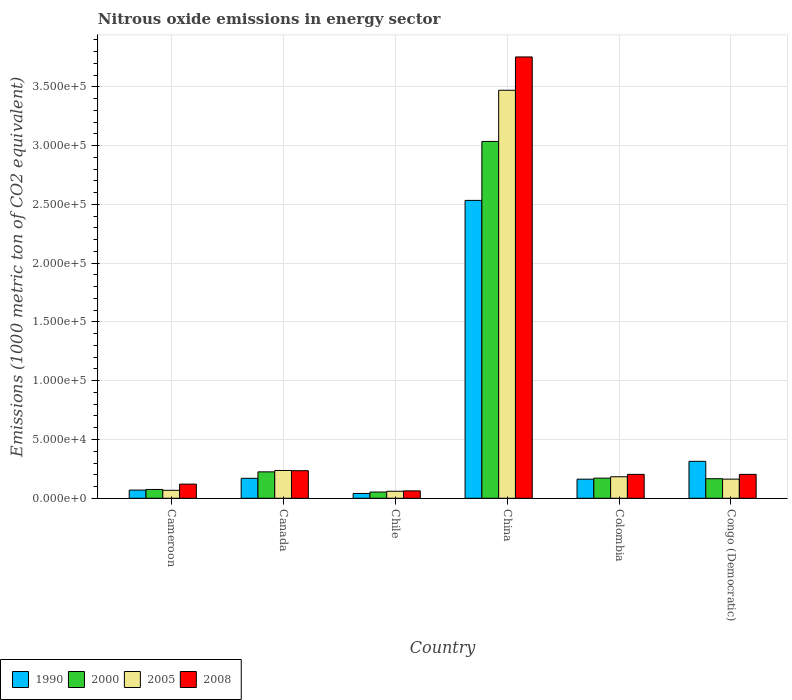How many different coloured bars are there?
Keep it short and to the point. 4. Are the number of bars on each tick of the X-axis equal?
Keep it short and to the point. Yes. What is the label of the 1st group of bars from the left?
Provide a succinct answer. Cameroon. In how many cases, is the number of bars for a given country not equal to the number of legend labels?
Your answer should be compact. 0. What is the amount of nitrous oxide emitted in 2008 in Canada?
Offer a very short reply. 2.34e+04. Across all countries, what is the maximum amount of nitrous oxide emitted in 2005?
Give a very brief answer. 3.47e+05. Across all countries, what is the minimum amount of nitrous oxide emitted in 2000?
Your answer should be very brief. 5305.7. What is the total amount of nitrous oxide emitted in 2008 in the graph?
Give a very brief answer. 4.58e+05. What is the difference between the amount of nitrous oxide emitted in 2005 in Colombia and that in Congo (Democratic)?
Offer a very short reply. 2014.7. What is the difference between the amount of nitrous oxide emitted in 2000 in Cameroon and the amount of nitrous oxide emitted in 1990 in China?
Your answer should be compact. -2.46e+05. What is the average amount of nitrous oxide emitted in 2000 per country?
Offer a very short reply. 6.21e+04. What is the difference between the amount of nitrous oxide emitted of/in 2000 and amount of nitrous oxide emitted of/in 2005 in Cameroon?
Ensure brevity in your answer.  719.7. What is the ratio of the amount of nitrous oxide emitted in 1990 in Chile to that in China?
Provide a short and direct response. 0.02. What is the difference between the highest and the second highest amount of nitrous oxide emitted in 2008?
Your answer should be very brief. 3108.7. What is the difference between the highest and the lowest amount of nitrous oxide emitted in 2000?
Ensure brevity in your answer.  2.98e+05. In how many countries, is the amount of nitrous oxide emitted in 2000 greater than the average amount of nitrous oxide emitted in 2000 taken over all countries?
Offer a very short reply. 1. Is the sum of the amount of nitrous oxide emitted in 2008 in Canada and Chile greater than the maximum amount of nitrous oxide emitted in 1990 across all countries?
Your response must be concise. No. Is it the case that in every country, the sum of the amount of nitrous oxide emitted in 2000 and amount of nitrous oxide emitted in 2005 is greater than the sum of amount of nitrous oxide emitted in 2008 and amount of nitrous oxide emitted in 1990?
Your answer should be compact. No. What does the 4th bar from the left in Colombia represents?
Your answer should be compact. 2008. What does the 4th bar from the right in China represents?
Provide a succinct answer. 1990. Are all the bars in the graph horizontal?
Offer a very short reply. No. How many countries are there in the graph?
Your answer should be compact. 6. Are the values on the major ticks of Y-axis written in scientific E-notation?
Offer a very short reply. Yes. Does the graph contain any zero values?
Make the answer very short. No. Does the graph contain grids?
Provide a succinct answer. Yes. How are the legend labels stacked?
Your answer should be compact. Horizontal. What is the title of the graph?
Your answer should be compact. Nitrous oxide emissions in energy sector. What is the label or title of the X-axis?
Make the answer very short. Country. What is the label or title of the Y-axis?
Provide a short and direct response. Emissions (1000 metric ton of CO2 equivalent). What is the Emissions (1000 metric ton of CO2 equivalent) in 1990 in Cameroon?
Ensure brevity in your answer.  6970.1. What is the Emissions (1000 metric ton of CO2 equivalent) in 2000 in Cameroon?
Offer a very short reply. 7501.6. What is the Emissions (1000 metric ton of CO2 equivalent) in 2005 in Cameroon?
Offer a very short reply. 6781.9. What is the Emissions (1000 metric ton of CO2 equivalent) of 2008 in Cameroon?
Keep it short and to the point. 1.21e+04. What is the Emissions (1000 metric ton of CO2 equivalent) of 1990 in Canada?
Provide a succinct answer. 1.70e+04. What is the Emissions (1000 metric ton of CO2 equivalent) of 2000 in Canada?
Give a very brief answer. 2.25e+04. What is the Emissions (1000 metric ton of CO2 equivalent) in 2005 in Canada?
Provide a succinct answer. 2.36e+04. What is the Emissions (1000 metric ton of CO2 equivalent) in 2008 in Canada?
Provide a succinct answer. 2.34e+04. What is the Emissions (1000 metric ton of CO2 equivalent) in 1990 in Chile?
Your response must be concise. 4097. What is the Emissions (1000 metric ton of CO2 equivalent) of 2000 in Chile?
Offer a very short reply. 5305.7. What is the Emissions (1000 metric ton of CO2 equivalent) in 2005 in Chile?
Ensure brevity in your answer.  5967.8. What is the Emissions (1000 metric ton of CO2 equivalent) in 2008 in Chile?
Your response must be concise. 6312. What is the Emissions (1000 metric ton of CO2 equivalent) in 1990 in China?
Your answer should be compact. 2.53e+05. What is the Emissions (1000 metric ton of CO2 equivalent) in 2000 in China?
Make the answer very short. 3.04e+05. What is the Emissions (1000 metric ton of CO2 equivalent) of 2005 in China?
Give a very brief answer. 3.47e+05. What is the Emissions (1000 metric ton of CO2 equivalent) in 2008 in China?
Your answer should be compact. 3.75e+05. What is the Emissions (1000 metric ton of CO2 equivalent) in 1990 in Colombia?
Provide a short and direct response. 1.63e+04. What is the Emissions (1000 metric ton of CO2 equivalent) of 2000 in Colombia?
Offer a very short reply. 1.71e+04. What is the Emissions (1000 metric ton of CO2 equivalent) of 2005 in Colombia?
Offer a very short reply. 1.83e+04. What is the Emissions (1000 metric ton of CO2 equivalent) of 2008 in Colombia?
Provide a succinct answer. 2.03e+04. What is the Emissions (1000 metric ton of CO2 equivalent) in 1990 in Congo (Democratic)?
Give a very brief answer. 3.14e+04. What is the Emissions (1000 metric ton of CO2 equivalent) of 2000 in Congo (Democratic)?
Keep it short and to the point. 1.66e+04. What is the Emissions (1000 metric ton of CO2 equivalent) in 2005 in Congo (Democratic)?
Keep it short and to the point. 1.63e+04. What is the Emissions (1000 metric ton of CO2 equivalent) of 2008 in Congo (Democratic)?
Your answer should be very brief. 2.03e+04. Across all countries, what is the maximum Emissions (1000 metric ton of CO2 equivalent) in 1990?
Provide a short and direct response. 2.53e+05. Across all countries, what is the maximum Emissions (1000 metric ton of CO2 equivalent) of 2000?
Offer a terse response. 3.04e+05. Across all countries, what is the maximum Emissions (1000 metric ton of CO2 equivalent) of 2005?
Make the answer very short. 3.47e+05. Across all countries, what is the maximum Emissions (1000 metric ton of CO2 equivalent) of 2008?
Your response must be concise. 3.75e+05. Across all countries, what is the minimum Emissions (1000 metric ton of CO2 equivalent) in 1990?
Give a very brief answer. 4097. Across all countries, what is the minimum Emissions (1000 metric ton of CO2 equivalent) in 2000?
Offer a terse response. 5305.7. Across all countries, what is the minimum Emissions (1000 metric ton of CO2 equivalent) of 2005?
Ensure brevity in your answer.  5967.8. Across all countries, what is the minimum Emissions (1000 metric ton of CO2 equivalent) in 2008?
Ensure brevity in your answer.  6312. What is the total Emissions (1000 metric ton of CO2 equivalent) in 1990 in the graph?
Give a very brief answer. 3.29e+05. What is the total Emissions (1000 metric ton of CO2 equivalent) of 2000 in the graph?
Ensure brevity in your answer.  3.73e+05. What is the total Emissions (1000 metric ton of CO2 equivalent) in 2005 in the graph?
Your answer should be compact. 4.18e+05. What is the total Emissions (1000 metric ton of CO2 equivalent) in 2008 in the graph?
Keep it short and to the point. 4.58e+05. What is the difference between the Emissions (1000 metric ton of CO2 equivalent) in 1990 in Cameroon and that in Canada?
Ensure brevity in your answer.  -1.00e+04. What is the difference between the Emissions (1000 metric ton of CO2 equivalent) in 2000 in Cameroon and that in Canada?
Your response must be concise. -1.50e+04. What is the difference between the Emissions (1000 metric ton of CO2 equivalent) of 2005 in Cameroon and that in Canada?
Give a very brief answer. -1.69e+04. What is the difference between the Emissions (1000 metric ton of CO2 equivalent) of 2008 in Cameroon and that in Canada?
Your answer should be very brief. -1.14e+04. What is the difference between the Emissions (1000 metric ton of CO2 equivalent) in 1990 in Cameroon and that in Chile?
Give a very brief answer. 2873.1. What is the difference between the Emissions (1000 metric ton of CO2 equivalent) of 2000 in Cameroon and that in Chile?
Provide a short and direct response. 2195.9. What is the difference between the Emissions (1000 metric ton of CO2 equivalent) of 2005 in Cameroon and that in Chile?
Provide a short and direct response. 814.1. What is the difference between the Emissions (1000 metric ton of CO2 equivalent) in 2008 in Cameroon and that in Chile?
Offer a terse response. 5740.9. What is the difference between the Emissions (1000 metric ton of CO2 equivalent) of 1990 in Cameroon and that in China?
Your answer should be compact. -2.46e+05. What is the difference between the Emissions (1000 metric ton of CO2 equivalent) of 2000 in Cameroon and that in China?
Your answer should be compact. -2.96e+05. What is the difference between the Emissions (1000 metric ton of CO2 equivalent) in 2005 in Cameroon and that in China?
Your answer should be compact. -3.40e+05. What is the difference between the Emissions (1000 metric ton of CO2 equivalent) in 2008 in Cameroon and that in China?
Provide a succinct answer. -3.63e+05. What is the difference between the Emissions (1000 metric ton of CO2 equivalent) in 1990 in Cameroon and that in Colombia?
Offer a very short reply. -9292. What is the difference between the Emissions (1000 metric ton of CO2 equivalent) in 2000 in Cameroon and that in Colombia?
Keep it short and to the point. -9624.9. What is the difference between the Emissions (1000 metric ton of CO2 equivalent) of 2005 in Cameroon and that in Colombia?
Provide a short and direct response. -1.15e+04. What is the difference between the Emissions (1000 metric ton of CO2 equivalent) of 2008 in Cameroon and that in Colombia?
Make the answer very short. -8286.7. What is the difference between the Emissions (1000 metric ton of CO2 equivalent) of 1990 in Cameroon and that in Congo (Democratic)?
Make the answer very short. -2.45e+04. What is the difference between the Emissions (1000 metric ton of CO2 equivalent) of 2000 in Cameroon and that in Congo (Democratic)?
Keep it short and to the point. -9135.6. What is the difference between the Emissions (1000 metric ton of CO2 equivalent) of 2005 in Cameroon and that in Congo (Democratic)?
Offer a very short reply. -9513.1. What is the difference between the Emissions (1000 metric ton of CO2 equivalent) of 2008 in Cameroon and that in Congo (Democratic)?
Make the answer very short. -8284.8. What is the difference between the Emissions (1000 metric ton of CO2 equivalent) of 1990 in Canada and that in Chile?
Offer a terse response. 1.29e+04. What is the difference between the Emissions (1000 metric ton of CO2 equivalent) of 2000 in Canada and that in Chile?
Give a very brief answer. 1.72e+04. What is the difference between the Emissions (1000 metric ton of CO2 equivalent) of 2005 in Canada and that in Chile?
Provide a short and direct response. 1.77e+04. What is the difference between the Emissions (1000 metric ton of CO2 equivalent) in 2008 in Canada and that in Chile?
Offer a very short reply. 1.71e+04. What is the difference between the Emissions (1000 metric ton of CO2 equivalent) of 1990 in Canada and that in China?
Your answer should be very brief. -2.36e+05. What is the difference between the Emissions (1000 metric ton of CO2 equivalent) in 2000 in Canada and that in China?
Offer a terse response. -2.81e+05. What is the difference between the Emissions (1000 metric ton of CO2 equivalent) of 2005 in Canada and that in China?
Give a very brief answer. -3.23e+05. What is the difference between the Emissions (1000 metric ton of CO2 equivalent) in 2008 in Canada and that in China?
Your answer should be very brief. -3.52e+05. What is the difference between the Emissions (1000 metric ton of CO2 equivalent) of 1990 in Canada and that in Colombia?
Keep it short and to the point. 737.3. What is the difference between the Emissions (1000 metric ton of CO2 equivalent) of 2000 in Canada and that in Colombia?
Give a very brief answer. 5354.3. What is the difference between the Emissions (1000 metric ton of CO2 equivalent) of 2005 in Canada and that in Colombia?
Ensure brevity in your answer.  5332.3. What is the difference between the Emissions (1000 metric ton of CO2 equivalent) of 2008 in Canada and that in Colombia?
Ensure brevity in your answer.  3108.7. What is the difference between the Emissions (1000 metric ton of CO2 equivalent) of 1990 in Canada and that in Congo (Democratic)?
Your answer should be very brief. -1.44e+04. What is the difference between the Emissions (1000 metric ton of CO2 equivalent) of 2000 in Canada and that in Congo (Democratic)?
Your answer should be compact. 5843.6. What is the difference between the Emissions (1000 metric ton of CO2 equivalent) of 2005 in Canada and that in Congo (Democratic)?
Your answer should be very brief. 7347. What is the difference between the Emissions (1000 metric ton of CO2 equivalent) of 2008 in Canada and that in Congo (Democratic)?
Offer a very short reply. 3110.6. What is the difference between the Emissions (1000 metric ton of CO2 equivalent) in 1990 in Chile and that in China?
Give a very brief answer. -2.49e+05. What is the difference between the Emissions (1000 metric ton of CO2 equivalent) in 2000 in Chile and that in China?
Keep it short and to the point. -2.98e+05. What is the difference between the Emissions (1000 metric ton of CO2 equivalent) of 2005 in Chile and that in China?
Make the answer very short. -3.41e+05. What is the difference between the Emissions (1000 metric ton of CO2 equivalent) in 2008 in Chile and that in China?
Make the answer very short. -3.69e+05. What is the difference between the Emissions (1000 metric ton of CO2 equivalent) in 1990 in Chile and that in Colombia?
Offer a terse response. -1.22e+04. What is the difference between the Emissions (1000 metric ton of CO2 equivalent) in 2000 in Chile and that in Colombia?
Offer a terse response. -1.18e+04. What is the difference between the Emissions (1000 metric ton of CO2 equivalent) in 2005 in Chile and that in Colombia?
Ensure brevity in your answer.  -1.23e+04. What is the difference between the Emissions (1000 metric ton of CO2 equivalent) of 2008 in Chile and that in Colombia?
Your answer should be very brief. -1.40e+04. What is the difference between the Emissions (1000 metric ton of CO2 equivalent) in 1990 in Chile and that in Congo (Democratic)?
Keep it short and to the point. -2.73e+04. What is the difference between the Emissions (1000 metric ton of CO2 equivalent) in 2000 in Chile and that in Congo (Democratic)?
Your answer should be very brief. -1.13e+04. What is the difference between the Emissions (1000 metric ton of CO2 equivalent) in 2005 in Chile and that in Congo (Democratic)?
Give a very brief answer. -1.03e+04. What is the difference between the Emissions (1000 metric ton of CO2 equivalent) of 2008 in Chile and that in Congo (Democratic)?
Your answer should be compact. -1.40e+04. What is the difference between the Emissions (1000 metric ton of CO2 equivalent) of 1990 in China and that in Colombia?
Your response must be concise. 2.37e+05. What is the difference between the Emissions (1000 metric ton of CO2 equivalent) in 2000 in China and that in Colombia?
Offer a terse response. 2.86e+05. What is the difference between the Emissions (1000 metric ton of CO2 equivalent) of 2005 in China and that in Colombia?
Keep it short and to the point. 3.29e+05. What is the difference between the Emissions (1000 metric ton of CO2 equivalent) in 2008 in China and that in Colombia?
Keep it short and to the point. 3.55e+05. What is the difference between the Emissions (1000 metric ton of CO2 equivalent) of 1990 in China and that in Congo (Democratic)?
Give a very brief answer. 2.22e+05. What is the difference between the Emissions (1000 metric ton of CO2 equivalent) of 2000 in China and that in Congo (Democratic)?
Offer a very short reply. 2.87e+05. What is the difference between the Emissions (1000 metric ton of CO2 equivalent) in 2005 in China and that in Congo (Democratic)?
Your answer should be very brief. 3.31e+05. What is the difference between the Emissions (1000 metric ton of CO2 equivalent) of 2008 in China and that in Congo (Democratic)?
Make the answer very short. 3.55e+05. What is the difference between the Emissions (1000 metric ton of CO2 equivalent) in 1990 in Colombia and that in Congo (Democratic)?
Offer a terse response. -1.52e+04. What is the difference between the Emissions (1000 metric ton of CO2 equivalent) of 2000 in Colombia and that in Congo (Democratic)?
Ensure brevity in your answer.  489.3. What is the difference between the Emissions (1000 metric ton of CO2 equivalent) in 2005 in Colombia and that in Congo (Democratic)?
Your answer should be very brief. 2014.7. What is the difference between the Emissions (1000 metric ton of CO2 equivalent) in 1990 in Cameroon and the Emissions (1000 metric ton of CO2 equivalent) in 2000 in Canada?
Provide a succinct answer. -1.55e+04. What is the difference between the Emissions (1000 metric ton of CO2 equivalent) in 1990 in Cameroon and the Emissions (1000 metric ton of CO2 equivalent) in 2005 in Canada?
Make the answer very short. -1.67e+04. What is the difference between the Emissions (1000 metric ton of CO2 equivalent) in 1990 in Cameroon and the Emissions (1000 metric ton of CO2 equivalent) in 2008 in Canada?
Offer a terse response. -1.65e+04. What is the difference between the Emissions (1000 metric ton of CO2 equivalent) in 2000 in Cameroon and the Emissions (1000 metric ton of CO2 equivalent) in 2005 in Canada?
Your answer should be very brief. -1.61e+04. What is the difference between the Emissions (1000 metric ton of CO2 equivalent) of 2000 in Cameroon and the Emissions (1000 metric ton of CO2 equivalent) of 2008 in Canada?
Your answer should be very brief. -1.59e+04. What is the difference between the Emissions (1000 metric ton of CO2 equivalent) in 2005 in Cameroon and the Emissions (1000 metric ton of CO2 equivalent) in 2008 in Canada?
Give a very brief answer. -1.67e+04. What is the difference between the Emissions (1000 metric ton of CO2 equivalent) of 1990 in Cameroon and the Emissions (1000 metric ton of CO2 equivalent) of 2000 in Chile?
Offer a very short reply. 1664.4. What is the difference between the Emissions (1000 metric ton of CO2 equivalent) of 1990 in Cameroon and the Emissions (1000 metric ton of CO2 equivalent) of 2005 in Chile?
Give a very brief answer. 1002.3. What is the difference between the Emissions (1000 metric ton of CO2 equivalent) of 1990 in Cameroon and the Emissions (1000 metric ton of CO2 equivalent) of 2008 in Chile?
Ensure brevity in your answer.  658.1. What is the difference between the Emissions (1000 metric ton of CO2 equivalent) in 2000 in Cameroon and the Emissions (1000 metric ton of CO2 equivalent) in 2005 in Chile?
Your response must be concise. 1533.8. What is the difference between the Emissions (1000 metric ton of CO2 equivalent) of 2000 in Cameroon and the Emissions (1000 metric ton of CO2 equivalent) of 2008 in Chile?
Your answer should be very brief. 1189.6. What is the difference between the Emissions (1000 metric ton of CO2 equivalent) of 2005 in Cameroon and the Emissions (1000 metric ton of CO2 equivalent) of 2008 in Chile?
Make the answer very short. 469.9. What is the difference between the Emissions (1000 metric ton of CO2 equivalent) in 1990 in Cameroon and the Emissions (1000 metric ton of CO2 equivalent) in 2000 in China?
Keep it short and to the point. -2.97e+05. What is the difference between the Emissions (1000 metric ton of CO2 equivalent) in 1990 in Cameroon and the Emissions (1000 metric ton of CO2 equivalent) in 2005 in China?
Keep it short and to the point. -3.40e+05. What is the difference between the Emissions (1000 metric ton of CO2 equivalent) of 1990 in Cameroon and the Emissions (1000 metric ton of CO2 equivalent) of 2008 in China?
Keep it short and to the point. -3.68e+05. What is the difference between the Emissions (1000 metric ton of CO2 equivalent) in 2000 in Cameroon and the Emissions (1000 metric ton of CO2 equivalent) in 2005 in China?
Your answer should be very brief. -3.40e+05. What is the difference between the Emissions (1000 metric ton of CO2 equivalent) of 2000 in Cameroon and the Emissions (1000 metric ton of CO2 equivalent) of 2008 in China?
Ensure brevity in your answer.  -3.68e+05. What is the difference between the Emissions (1000 metric ton of CO2 equivalent) in 2005 in Cameroon and the Emissions (1000 metric ton of CO2 equivalent) in 2008 in China?
Your answer should be compact. -3.69e+05. What is the difference between the Emissions (1000 metric ton of CO2 equivalent) of 1990 in Cameroon and the Emissions (1000 metric ton of CO2 equivalent) of 2000 in Colombia?
Make the answer very short. -1.02e+04. What is the difference between the Emissions (1000 metric ton of CO2 equivalent) of 1990 in Cameroon and the Emissions (1000 metric ton of CO2 equivalent) of 2005 in Colombia?
Ensure brevity in your answer.  -1.13e+04. What is the difference between the Emissions (1000 metric ton of CO2 equivalent) in 1990 in Cameroon and the Emissions (1000 metric ton of CO2 equivalent) in 2008 in Colombia?
Provide a succinct answer. -1.34e+04. What is the difference between the Emissions (1000 metric ton of CO2 equivalent) in 2000 in Cameroon and the Emissions (1000 metric ton of CO2 equivalent) in 2005 in Colombia?
Your answer should be compact. -1.08e+04. What is the difference between the Emissions (1000 metric ton of CO2 equivalent) of 2000 in Cameroon and the Emissions (1000 metric ton of CO2 equivalent) of 2008 in Colombia?
Offer a very short reply. -1.28e+04. What is the difference between the Emissions (1000 metric ton of CO2 equivalent) of 2005 in Cameroon and the Emissions (1000 metric ton of CO2 equivalent) of 2008 in Colombia?
Ensure brevity in your answer.  -1.36e+04. What is the difference between the Emissions (1000 metric ton of CO2 equivalent) of 1990 in Cameroon and the Emissions (1000 metric ton of CO2 equivalent) of 2000 in Congo (Democratic)?
Provide a short and direct response. -9667.1. What is the difference between the Emissions (1000 metric ton of CO2 equivalent) of 1990 in Cameroon and the Emissions (1000 metric ton of CO2 equivalent) of 2005 in Congo (Democratic)?
Make the answer very short. -9324.9. What is the difference between the Emissions (1000 metric ton of CO2 equivalent) of 1990 in Cameroon and the Emissions (1000 metric ton of CO2 equivalent) of 2008 in Congo (Democratic)?
Give a very brief answer. -1.34e+04. What is the difference between the Emissions (1000 metric ton of CO2 equivalent) of 2000 in Cameroon and the Emissions (1000 metric ton of CO2 equivalent) of 2005 in Congo (Democratic)?
Ensure brevity in your answer.  -8793.4. What is the difference between the Emissions (1000 metric ton of CO2 equivalent) in 2000 in Cameroon and the Emissions (1000 metric ton of CO2 equivalent) in 2008 in Congo (Democratic)?
Provide a succinct answer. -1.28e+04. What is the difference between the Emissions (1000 metric ton of CO2 equivalent) of 2005 in Cameroon and the Emissions (1000 metric ton of CO2 equivalent) of 2008 in Congo (Democratic)?
Provide a succinct answer. -1.36e+04. What is the difference between the Emissions (1000 metric ton of CO2 equivalent) of 1990 in Canada and the Emissions (1000 metric ton of CO2 equivalent) of 2000 in Chile?
Keep it short and to the point. 1.17e+04. What is the difference between the Emissions (1000 metric ton of CO2 equivalent) in 1990 in Canada and the Emissions (1000 metric ton of CO2 equivalent) in 2005 in Chile?
Your answer should be compact. 1.10e+04. What is the difference between the Emissions (1000 metric ton of CO2 equivalent) in 1990 in Canada and the Emissions (1000 metric ton of CO2 equivalent) in 2008 in Chile?
Provide a short and direct response. 1.07e+04. What is the difference between the Emissions (1000 metric ton of CO2 equivalent) of 2000 in Canada and the Emissions (1000 metric ton of CO2 equivalent) of 2005 in Chile?
Your answer should be compact. 1.65e+04. What is the difference between the Emissions (1000 metric ton of CO2 equivalent) of 2000 in Canada and the Emissions (1000 metric ton of CO2 equivalent) of 2008 in Chile?
Ensure brevity in your answer.  1.62e+04. What is the difference between the Emissions (1000 metric ton of CO2 equivalent) in 2005 in Canada and the Emissions (1000 metric ton of CO2 equivalent) in 2008 in Chile?
Your answer should be compact. 1.73e+04. What is the difference between the Emissions (1000 metric ton of CO2 equivalent) in 1990 in Canada and the Emissions (1000 metric ton of CO2 equivalent) in 2000 in China?
Give a very brief answer. -2.87e+05. What is the difference between the Emissions (1000 metric ton of CO2 equivalent) of 1990 in Canada and the Emissions (1000 metric ton of CO2 equivalent) of 2005 in China?
Keep it short and to the point. -3.30e+05. What is the difference between the Emissions (1000 metric ton of CO2 equivalent) in 1990 in Canada and the Emissions (1000 metric ton of CO2 equivalent) in 2008 in China?
Your answer should be very brief. -3.58e+05. What is the difference between the Emissions (1000 metric ton of CO2 equivalent) of 2000 in Canada and the Emissions (1000 metric ton of CO2 equivalent) of 2005 in China?
Give a very brief answer. -3.25e+05. What is the difference between the Emissions (1000 metric ton of CO2 equivalent) in 2000 in Canada and the Emissions (1000 metric ton of CO2 equivalent) in 2008 in China?
Make the answer very short. -3.53e+05. What is the difference between the Emissions (1000 metric ton of CO2 equivalent) of 2005 in Canada and the Emissions (1000 metric ton of CO2 equivalent) of 2008 in China?
Provide a short and direct response. -3.52e+05. What is the difference between the Emissions (1000 metric ton of CO2 equivalent) in 1990 in Canada and the Emissions (1000 metric ton of CO2 equivalent) in 2000 in Colombia?
Provide a succinct answer. -127.1. What is the difference between the Emissions (1000 metric ton of CO2 equivalent) in 1990 in Canada and the Emissions (1000 metric ton of CO2 equivalent) in 2005 in Colombia?
Your response must be concise. -1310.3. What is the difference between the Emissions (1000 metric ton of CO2 equivalent) of 1990 in Canada and the Emissions (1000 metric ton of CO2 equivalent) of 2008 in Colombia?
Make the answer very short. -3340.2. What is the difference between the Emissions (1000 metric ton of CO2 equivalent) in 2000 in Canada and the Emissions (1000 metric ton of CO2 equivalent) in 2005 in Colombia?
Offer a very short reply. 4171.1. What is the difference between the Emissions (1000 metric ton of CO2 equivalent) in 2000 in Canada and the Emissions (1000 metric ton of CO2 equivalent) in 2008 in Colombia?
Offer a very short reply. 2141.2. What is the difference between the Emissions (1000 metric ton of CO2 equivalent) of 2005 in Canada and the Emissions (1000 metric ton of CO2 equivalent) of 2008 in Colombia?
Ensure brevity in your answer.  3302.4. What is the difference between the Emissions (1000 metric ton of CO2 equivalent) in 1990 in Canada and the Emissions (1000 metric ton of CO2 equivalent) in 2000 in Congo (Democratic)?
Ensure brevity in your answer.  362.2. What is the difference between the Emissions (1000 metric ton of CO2 equivalent) in 1990 in Canada and the Emissions (1000 metric ton of CO2 equivalent) in 2005 in Congo (Democratic)?
Provide a short and direct response. 704.4. What is the difference between the Emissions (1000 metric ton of CO2 equivalent) of 1990 in Canada and the Emissions (1000 metric ton of CO2 equivalent) of 2008 in Congo (Democratic)?
Give a very brief answer. -3338.3. What is the difference between the Emissions (1000 metric ton of CO2 equivalent) of 2000 in Canada and the Emissions (1000 metric ton of CO2 equivalent) of 2005 in Congo (Democratic)?
Give a very brief answer. 6185.8. What is the difference between the Emissions (1000 metric ton of CO2 equivalent) of 2000 in Canada and the Emissions (1000 metric ton of CO2 equivalent) of 2008 in Congo (Democratic)?
Make the answer very short. 2143.1. What is the difference between the Emissions (1000 metric ton of CO2 equivalent) of 2005 in Canada and the Emissions (1000 metric ton of CO2 equivalent) of 2008 in Congo (Democratic)?
Ensure brevity in your answer.  3304.3. What is the difference between the Emissions (1000 metric ton of CO2 equivalent) of 1990 in Chile and the Emissions (1000 metric ton of CO2 equivalent) of 2000 in China?
Make the answer very short. -2.99e+05. What is the difference between the Emissions (1000 metric ton of CO2 equivalent) in 1990 in Chile and the Emissions (1000 metric ton of CO2 equivalent) in 2005 in China?
Your response must be concise. -3.43e+05. What is the difference between the Emissions (1000 metric ton of CO2 equivalent) in 1990 in Chile and the Emissions (1000 metric ton of CO2 equivalent) in 2008 in China?
Provide a short and direct response. -3.71e+05. What is the difference between the Emissions (1000 metric ton of CO2 equivalent) in 2000 in Chile and the Emissions (1000 metric ton of CO2 equivalent) in 2005 in China?
Your response must be concise. -3.42e+05. What is the difference between the Emissions (1000 metric ton of CO2 equivalent) in 2000 in Chile and the Emissions (1000 metric ton of CO2 equivalent) in 2008 in China?
Your answer should be very brief. -3.70e+05. What is the difference between the Emissions (1000 metric ton of CO2 equivalent) in 2005 in Chile and the Emissions (1000 metric ton of CO2 equivalent) in 2008 in China?
Give a very brief answer. -3.69e+05. What is the difference between the Emissions (1000 metric ton of CO2 equivalent) of 1990 in Chile and the Emissions (1000 metric ton of CO2 equivalent) of 2000 in Colombia?
Provide a succinct answer. -1.30e+04. What is the difference between the Emissions (1000 metric ton of CO2 equivalent) of 1990 in Chile and the Emissions (1000 metric ton of CO2 equivalent) of 2005 in Colombia?
Your answer should be compact. -1.42e+04. What is the difference between the Emissions (1000 metric ton of CO2 equivalent) of 1990 in Chile and the Emissions (1000 metric ton of CO2 equivalent) of 2008 in Colombia?
Keep it short and to the point. -1.62e+04. What is the difference between the Emissions (1000 metric ton of CO2 equivalent) of 2000 in Chile and the Emissions (1000 metric ton of CO2 equivalent) of 2005 in Colombia?
Keep it short and to the point. -1.30e+04. What is the difference between the Emissions (1000 metric ton of CO2 equivalent) in 2000 in Chile and the Emissions (1000 metric ton of CO2 equivalent) in 2008 in Colombia?
Your response must be concise. -1.50e+04. What is the difference between the Emissions (1000 metric ton of CO2 equivalent) of 2005 in Chile and the Emissions (1000 metric ton of CO2 equivalent) of 2008 in Colombia?
Give a very brief answer. -1.44e+04. What is the difference between the Emissions (1000 metric ton of CO2 equivalent) in 1990 in Chile and the Emissions (1000 metric ton of CO2 equivalent) in 2000 in Congo (Democratic)?
Make the answer very short. -1.25e+04. What is the difference between the Emissions (1000 metric ton of CO2 equivalent) in 1990 in Chile and the Emissions (1000 metric ton of CO2 equivalent) in 2005 in Congo (Democratic)?
Your response must be concise. -1.22e+04. What is the difference between the Emissions (1000 metric ton of CO2 equivalent) in 1990 in Chile and the Emissions (1000 metric ton of CO2 equivalent) in 2008 in Congo (Democratic)?
Your answer should be very brief. -1.62e+04. What is the difference between the Emissions (1000 metric ton of CO2 equivalent) of 2000 in Chile and the Emissions (1000 metric ton of CO2 equivalent) of 2005 in Congo (Democratic)?
Keep it short and to the point. -1.10e+04. What is the difference between the Emissions (1000 metric ton of CO2 equivalent) of 2000 in Chile and the Emissions (1000 metric ton of CO2 equivalent) of 2008 in Congo (Democratic)?
Make the answer very short. -1.50e+04. What is the difference between the Emissions (1000 metric ton of CO2 equivalent) of 2005 in Chile and the Emissions (1000 metric ton of CO2 equivalent) of 2008 in Congo (Democratic)?
Your answer should be very brief. -1.44e+04. What is the difference between the Emissions (1000 metric ton of CO2 equivalent) of 1990 in China and the Emissions (1000 metric ton of CO2 equivalent) of 2000 in Colombia?
Your answer should be very brief. 2.36e+05. What is the difference between the Emissions (1000 metric ton of CO2 equivalent) in 1990 in China and the Emissions (1000 metric ton of CO2 equivalent) in 2005 in Colombia?
Your answer should be very brief. 2.35e+05. What is the difference between the Emissions (1000 metric ton of CO2 equivalent) in 1990 in China and the Emissions (1000 metric ton of CO2 equivalent) in 2008 in Colombia?
Offer a terse response. 2.33e+05. What is the difference between the Emissions (1000 metric ton of CO2 equivalent) in 2000 in China and the Emissions (1000 metric ton of CO2 equivalent) in 2005 in Colombia?
Provide a succinct answer. 2.85e+05. What is the difference between the Emissions (1000 metric ton of CO2 equivalent) of 2000 in China and the Emissions (1000 metric ton of CO2 equivalent) of 2008 in Colombia?
Offer a terse response. 2.83e+05. What is the difference between the Emissions (1000 metric ton of CO2 equivalent) of 2005 in China and the Emissions (1000 metric ton of CO2 equivalent) of 2008 in Colombia?
Offer a terse response. 3.27e+05. What is the difference between the Emissions (1000 metric ton of CO2 equivalent) in 1990 in China and the Emissions (1000 metric ton of CO2 equivalent) in 2000 in Congo (Democratic)?
Provide a succinct answer. 2.37e+05. What is the difference between the Emissions (1000 metric ton of CO2 equivalent) of 1990 in China and the Emissions (1000 metric ton of CO2 equivalent) of 2005 in Congo (Democratic)?
Provide a short and direct response. 2.37e+05. What is the difference between the Emissions (1000 metric ton of CO2 equivalent) in 1990 in China and the Emissions (1000 metric ton of CO2 equivalent) in 2008 in Congo (Democratic)?
Offer a terse response. 2.33e+05. What is the difference between the Emissions (1000 metric ton of CO2 equivalent) in 2000 in China and the Emissions (1000 metric ton of CO2 equivalent) in 2005 in Congo (Democratic)?
Keep it short and to the point. 2.87e+05. What is the difference between the Emissions (1000 metric ton of CO2 equivalent) in 2000 in China and the Emissions (1000 metric ton of CO2 equivalent) in 2008 in Congo (Democratic)?
Give a very brief answer. 2.83e+05. What is the difference between the Emissions (1000 metric ton of CO2 equivalent) in 2005 in China and the Emissions (1000 metric ton of CO2 equivalent) in 2008 in Congo (Democratic)?
Give a very brief answer. 3.27e+05. What is the difference between the Emissions (1000 metric ton of CO2 equivalent) of 1990 in Colombia and the Emissions (1000 metric ton of CO2 equivalent) of 2000 in Congo (Democratic)?
Keep it short and to the point. -375.1. What is the difference between the Emissions (1000 metric ton of CO2 equivalent) of 1990 in Colombia and the Emissions (1000 metric ton of CO2 equivalent) of 2005 in Congo (Democratic)?
Your answer should be very brief. -32.9. What is the difference between the Emissions (1000 metric ton of CO2 equivalent) of 1990 in Colombia and the Emissions (1000 metric ton of CO2 equivalent) of 2008 in Congo (Democratic)?
Your answer should be compact. -4075.6. What is the difference between the Emissions (1000 metric ton of CO2 equivalent) of 2000 in Colombia and the Emissions (1000 metric ton of CO2 equivalent) of 2005 in Congo (Democratic)?
Offer a very short reply. 831.5. What is the difference between the Emissions (1000 metric ton of CO2 equivalent) in 2000 in Colombia and the Emissions (1000 metric ton of CO2 equivalent) in 2008 in Congo (Democratic)?
Offer a terse response. -3211.2. What is the difference between the Emissions (1000 metric ton of CO2 equivalent) in 2005 in Colombia and the Emissions (1000 metric ton of CO2 equivalent) in 2008 in Congo (Democratic)?
Offer a terse response. -2028. What is the average Emissions (1000 metric ton of CO2 equivalent) in 1990 per country?
Offer a very short reply. 5.49e+04. What is the average Emissions (1000 metric ton of CO2 equivalent) in 2000 per country?
Offer a very short reply. 6.21e+04. What is the average Emissions (1000 metric ton of CO2 equivalent) of 2005 per country?
Make the answer very short. 6.97e+04. What is the average Emissions (1000 metric ton of CO2 equivalent) of 2008 per country?
Provide a short and direct response. 7.63e+04. What is the difference between the Emissions (1000 metric ton of CO2 equivalent) in 1990 and Emissions (1000 metric ton of CO2 equivalent) in 2000 in Cameroon?
Provide a succinct answer. -531.5. What is the difference between the Emissions (1000 metric ton of CO2 equivalent) in 1990 and Emissions (1000 metric ton of CO2 equivalent) in 2005 in Cameroon?
Offer a very short reply. 188.2. What is the difference between the Emissions (1000 metric ton of CO2 equivalent) in 1990 and Emissions (1000 metric ton of CO2 equivalent) in 2008 in Cameroon?
Ensure brevity in your answer.  -5082.8. What is the difference between the Emissions (1000 metric ton of CO2 equivalent) in 2000 and Emissions (1000 metric ton of CO2 equivalent) in 2005 in Cameroon?
Make the answer very short. 719.7. What is the difference between the Emissions (1000 metric ton of CO2 equivalent) in 2000 and Emissions (1000 metric ton of CO2 equivalent) in 2008 in Cameroon?
Offer a very short reply. -4551.3. What is the difference between the Emissions (1000 metric ton of CO2 equivalent) in 2005 and Emissions (1000 metric ton of CO2 equivalent) in 2008 in Cameroon?
Provide a succinct answer. -5271. What is the difference between the Emissions (1000 metric ton of CO2 equivalent) in 1990 and Emissions (1000 metric ton of CO2 equivalent) in 2000 in Canada?
Offer a terse response. -5481.4. What is the difference between the Emissions (1000 metric ton of CO2 equivalent) of 1990 and Emissions (1000 metric ton of CO2 equivalent) of 2005 in Canada?
Offer a terse response. -6642.6. What is the difference between the Emissions (1000 metric ton of CO2 equivalent) in 1990 and Emissions (1000 metric ton of CO2 equivalent) in 2008 in Canada?
Offer a terse response. -6448.9. What is the difference between the Emissions (1000 metric ton of CO2 equivalent) in 2000 and Emissions (1000 metric ton of CO2 equivalent) in 2005 in Canada?
Your answer should be very brief. -1161.2. What is the difference between the Emissions (1000 metric ton of CO2 equivalent) in 2000 and Emissions (1000 metric ton of CO2 equivalent) in 2008 in Canada?
Make the answer very short. -967.5. What is the difference between the Emissions (1000 metric ton of CO2 equivalent) of 2005 and Emissions (1000 metric ton of CO2 equivalent) of 2008 in Canada?
Your response must be concise. 193.7. What is the difference between the Emissions (1000 metric ton of CO2 equivalent) of 1990 and Emissions (1000 metric ton of CO2 equivalent) of 2000 in Chile?
Make the answer very short. -1208.7. What is the difference between the Emissions (1000 metric ton of CO2 equivalent) of 1990 and Emissions (1000 metric ton of CO2 equivalent) of 2005 in Chile?
Your answer should be compact. -1870.8. What is the difference between the Emissions (1000 metric ton of CO2 equivalent) in 1990 and Emissions (1000 metric ton of CO2 equivalent) in 2008 in Chile?
Offer a terse response. -2215. What is the difference between the Emissions (1000 metric ton of CO2 equivalent) in 2000 and Emissions (1000 metric ton of CO2 equivalent) in 2005 in Chile?
Make the answer very short. -662.1. What is the difference between the Emissions (1000 metric ton of CO2 equivalent) in 2000 and Emissions (1000 metric ton of CO2 equivalent) in 2008 in Chile?
Offer a terse response. -1006.3. What is the difference between the Emissions (1000 metric ton of CO2 equivalent) of 2005 and Emissions (1000 metric ton of CO2 equivalent) of 2008 in Chile?
Make the answer very short. -344.2. What is the difference between the Emissions (1000 metric ton of CO2 equivalent) of 1990 and Emissions (1000 metric ton of CO2 equivalent) of 2000 in China?
Keep it short and to the point. -5.02e+04. What is the difference between the Emissions (1000 metric ton of CO2 equivalent) in 1990 and Emissions (1000 metric ton of CO2 equivalent) in 2005 in China?
Your answer should be very brief. -9.37e+04. What is the difference between the Emissions (1000 metric ton of CO2 equivalent) of 1990 and Emissions (1000 metric ton of CO2 equivalent) of 2008 in China?
Your response must be concise. -1.22e+05. What is the difference between the Emissions (1000 metric ton of CO2 equivalent) in 2000 and Emissions (1000 metric ton of CO2 equivalent) in 2005 in China?
Provide a short and direct response. -4.35e+04. What is the difference between the Emissions (1000 metric ton of CO2 equivalent) in 2000 and Emissions (1000 metric ton of CO2 equivalent) in 2008 in China?
Your answer should be very brief. -7.19e+04. What is the difference between the Emissions (1000 metric ton of CO2 equivalent) of 2005 and Emissions (1000 metric ton of CO2 equivalent) of 2008 in China?
Ensure brevity in your answer.  -2.83e+04. What is the difference between the Emissions (1000 metric ton of CO2 equivalent) of 1990 and Emissions (1000 metric ton of CO2 equivalent) of 2000 in Colombia?
Your answer should be very brief. -864.4. What is the difference between the Emissions (1000 metric ton of CO2 equivalent) in 1990 and Emissions (1000 metric ton of CO2 equivalent) in 2005 in Colombia?
Give a very brief answer. -2047.6. What is the difference between the Emissions (1000 metric ton of CO2 equivalent) in 1990 and Emissions (1000 metric ton of CO2 equivalent) in 2008 in Colombia?
Make the answer very short. -4077.5. What is the difference between the Emissions (1000 metric ton of CO2 equivalent) of 2000 and Emissions (1000 metric ton of CO2 equivalent) of 2005 in Colombia?
Your answer should be compact. -1183.2. What is the difference between the Emissions (1000 metric ton of CO2 equivalent) of 2000 and Emissions (1000 metric ton of CO2 equivalent) of 2008 in Colombia?
Your answer should be very brief. -3213.1. What is the difference between the Emissions (1000 metric ton of CO2 equivalent) in 2005 and Emissions (1000 metric ton of CO2 equivalent) in 2008 in Colombia?
Give a very brief answer. -2029.9. What is the difference between the Emissions (1000 metric ton of CO2 equivalent) of 1990 and Emissions (1000 metric ton of CO2 equivalent) of 2000 in Congo (Democratic)?
Your response must be concise. 1.48e+04. What is the difference between the Emissions (1000 metric ton of CO2 equivalent) of 1990 and Emissions (1000 metric ton of CO2 equivalent) of 2005 in Congo (Democratic)?
Provide a succinct answer. 1.51e+04. What is the difference between the Emissions (1000 metric ton of CO2 equivalent) in 1990 and Emissions (1000 metric ton of CO2 equivalent) in 2008 in Congo (Democratic)?
Your answer should be compact. 1.11e+04. What is the difference between the Emissions (1000 metric ton of CO2 equivalent) in 2000 and Emissions (1000 metric ton of CO2 equivalent) in 2005 in Congo (Democratic)?
Give a very brief answer. 342.2. What is the difference between the Emissions (1000 metric ton of CO2 equivalent) of 2000 and Emissions (1000 metric ton of CO2 equivalent) of 2008 in Congo (Democratic)?
Offer a terse response. -3700.5. What is the difference between the Emissions (1000 metric ton of CO2 equivalent) of 2005 and Emissions (1000 metric ton of CO2 equivalent) of 2008 in Congo (Democratic)?
Your response must be concise. -4042.7. What is the ratio of the Emissions (1000 metric ton of CO2 equivalent) in 1990 in Cameroon to that in Canada?
Your answer should be compact. 0.41. What is the ratio of the Emissions (1000 metric ton of CO2 equivalent) in 2000 in Cameroon to that in Canada?
Make the answer very short. 0.33. What is the ratio of the Emissions (1000 metric ton of CO2 equivalent) in 2005 in Cameroon to that in Canada?
Your answer should be compact. 0.29. What is the ratio of the Emissions (1000 metric ton of CO2 equivalent) in 2008 in Cameroon to that in Canada?
Provide a short and direct response. 0.51. What is the ratio of the Emissions (1000 metric ton of CO2 equivalent) of 1990 in Cameroon to that in Chile?
Ensure brevity in your answer.  1.7. What is the ratio of the Emissions (1000 metric ton of CO2 equivalent) in 2000 in Cameroon to that in Chile?
Provide a short and direct response. 1.41. What is the ratio of the Emissions (1000 metric ton of CO2 equivalent) of 2005 in Cameroon to that in Chile?
Your answer should be compact. 1.14. What is the ratio of the Emissions (1000 metric ton of CO2 equivalent) in 2008 in Cameroon to that in Chile?
Make the answer very short. 1.91. What is the ratio of the Emissions (1000 metric ton of CO2 equivalent) in 1990 in Cameroon to that in China?
Keep it short and to the point. 0.03. What is the ratio of the Emissions (1000 metric ton of CO2 equivalent) in 2000 in Cameroon to that in China?
Your response must be concise. 0.02. What is the ratio of the Emissions (1000 metric ton of CO2 equivalent) of 2005 in Cameroon to that in China?
Give a very brief answer. 0.02. What is the ratio of the Emissions (1000 metric ton of CO2 equivalent) of 2008 in Cameroon to that in China?
Ensure brevity in your answer.  0.03. What is the ratio of the Emissions (1000 metric ton of CO2 equivalent) of 1990 in Cameroon to that in Colombia?
Your answer should be very brief. 0.43. What is the ratio of the Emissions (1000 metric ton of CO2 equivalent) of 2000 in Cameroon to that in Colombia?
Your response must be concise. 0.44. What is the ratio of the Emissions (1000 metric ton of CO2 equivalent) of 2005 in Cameroon to that in Colombia?
Ensure brevity in your answer.  0.37. What is the ratio of the Emissions (1000 metric ton of CO2 equivalent) of 2008 in Cameroon to that in Colombia?
Your response must be concise. 0.59. What is the ratio of the Emissions (1000 metric ton of CO2 equivalent) of 1990 in Cameroon to that in Congo (Democratic)?
Offer a terse response. 0.22. What is the ratio of the Emissions (1000 metric ton of CO2 equivalent) in 2000 in Cameroon to that in Congo (Democratic)?
Offer a very short reply. 0.45. What is the ratio of the Emissions (1000 metric ton of CO2 equivalent) of 2005 in Cameroon to that in Congo (Democratic)?
Your answer should be compact. 0.42. What is the ratio of the Emissions (1000 metric ton of CO2 equivalent) in 2008 in Cameroon to that in Congo (Democratic)?
Give a very brief answer. 0.59. What is the ratio of the Emissions (1000 metric ton of CO2 equivalent) in 1990 in Canada to that in Chile?
Provide a succinct answer. 4.15. What is the ratio of the Emissions (1000 metric ton of CO2 equivalent) in 2000 in Canada to that in Chile?
Offer a terse response. 4.24. What is the ratio of the Emissions (1000 metric ton of CO2 equivalent) of 2005 in Canada to that in Chile?
Offer a terse response. 3.96. What is the ratio of the Emissions (1000 metric ton of CO2 equivalent) of 2008 in Canada to that in Chile?
Make the answer very short. 3.71. What is the ratio of the Emissions (1000 metric ton of CO2 equivalent) in 1990 in Canada to that in China?
Offer a terse response. 0.07. What is the ratio of the Emissions (1000 metric ton of CO2 equivalent) of 2000 in Canada to that in China?
Your response must be concise. 0.07. What is the ratio of the Emissions (1000 metric ton of CO2 equivalent) of 2005 in Canada to that in China?
Give a very brief answer. 0.07. What is the ratio of the Emissions (1000 metric ton of CO2 equivalent) of 2008 in Canada to that in China?
Give a very brief answer. 0.06. What is the ratio of the Emissions (1000 metric ton of CO2 equivalent) in 1990 in Canada to that in Colombia?
Your response must be concise. 1.05. What is the ratio of the Emissions (1000 metric ton of CO2 equivalent) of 2000 in Canada to that in Colombia?
Ensure brevity in your answer.  1.31. What is the ratio of the Emissions (1000 metric ton of CO2 equivalent) in 2005 in Canada to that in Colombia?
Keep it short and to the point. 1.29. What is the ratio of the Emissions (1000 metric ton of CO2 equivalent) of 2008 in Canada to that in Colombia?
Your answer should be compact. 1.15. What is the ratio of the Emissions (1000 metric ton of CO2 equivalent) in 1990 in Canada to that in Congo (Democratic)?
Give a very brief answer. 0.54. What is the ratio of the Emissions (1000 metric ton of CO2 equivalent) of 2000 in Canada to that in Congo (Democratic)?
Your answer should be very brief. 1.35. What is the ratio of the Emissions (1000 metric ton of CO2 equivalent) in 2005 in Canada to that in Congo (Democratic)?
Give a very brief answer. 1.45. What is the ratio of the Emissions (1000 metric ton of CO2 equivalent) of 2008 in Canada to that in Congo (Democratic)?
Keep it short and to the point. 1.15. What is the ratio of the Emissions (1000 metric ton of CO2 equivalent) of 1990 in Chile to that in China?
Your answer should be compact. 0.02. What is the ratio of the Emissions (1000 metric ton of CO2 equivalent) of 2000 in Chile to that in China?
Provide a succinct answer. 0.02. What is the ratio of the Emissions (1000 metric ton of CO2 equivalent) of 2005 in Chile to that in China?
Make the answer very short. 0.02. What is the ratio of the Emissions (1000 metric ton of CO2 equivalent) in 2008 in Chile to that in China?
Ensure brevity in your answer.  0.02. What is the ratio of the Emissions (1000 metric ton of CO2 equivalent) in 1990 in Chile to that in Colombia?
Your answer should be very brief. 0.25. What is the ratio of the Emissions (1000 metric ton of CO2 equivalent) in 2000 in Chile to that in Colombia?
Keep it short and to the point. 0.31. What is the ratio of the Emissions (1000 metric ton of CO2 equivalent) in 2005 in Chile to that in Colombia?
Provide a short and direct response. 0.33. What is the ratio of the Emissions (1000 metric ton of CO2 equivalent) in 2008 in Chile to that in Colombia?
Your answer should be very brief. 0.31. What is the ratio of the Emissions (1000 metric ton of CO2 equivalent) in 1990 in Chile to that in Congo (Democratic)?
Your answer should be very brief. 0.13. What is the ratio of the Emissions (1000 metric ton of CO2 equivalent) of 2000 in Chile to that in Congo (Democratic)?
Give a very brief answer. 0.32. What is the ratio of the Emissions (1000 metric ton of CO2 equivalent) of 2005 in Chile to that in Congo (Democratic)?
Provide a short and direct response. 0.37. What is the ratio of the Emissions (1000 metric ton of CO2 equivalent) of 2008 in Chile to that in Congo (Democratic)?
Offer a very short reply. 0.31. What is the ratio of the Emissions (1000 metric ton of CO2 equivalent) of 1990 in China to that in Colombia?
Provide a succinct answer. 15.58. What is the ratio of the Emissions (1000 metric ton of CO2 equivalent) in 2000 in China to that in Colombia?
Ensure brevity in your answer.  17.72. What is the ratio of the Emissions (1000 metric ton of CO2 equivalent) in 2005 in China to that in Colombia?
Offer a terse response. 18.96. What is the ratio of the Emissions (1000 metric ton of CO2 equivalent) of 2008 in China to that in Colombia?
Offer a terse response. 18.46. What is the ratio of the Emissions (1000 metric ton of CO2 equivalent) of 1990 in China to that in Congo (Democratic)?
Your response must be concise. 8.06. What is the ratio of the Emissions (1000 metric ton of CO2 equivalent) in 2000 in China to that in Congo (Democratic)?
Offer a very short reply. 18.25. What is the ratio of the Emissions (1000 metric ton of CO2 equivalent) in 2005 in China to that in Congo (Democratic)?
Keep it short and to the point. 21.3. What is the ratio of the Emissions (1000 metric ton of CO2 equivalent) of 2008 in China to that in Congo (Democratic)?
Provide a short and direct response. 18.46. What is the ratio of the Emissions (1000 metric ton of CO2 equivalent) of 1990 in Colombia to that in Congo (Democratic)?
Your answer should be very brief. 0.52. What is the ratio of the Emissions (1000 metric ton of CO2 equivalent) in 2000 in Colombia to that in Congo (Democratic)?
Your response must be concise. 1.03. What is the ratio of the Emissions (1000 metric ton of CO2 equivalent) of 2005 in Colombia to that in Congo (Democratic)?
Provide a short and direct response. 1.12. What is the ratio of the Emissions (1000 metric ton of CO2 equivalent) of 2008 in Colombia to that in Congo (Democratic)?
Make the answer very short. 1. What is the difference between the highest and the second highest Emissions (1000 metric ton of CO2 equivalent) in 1990?
Keep it short and to the point. 2.22e+05. What is the difference between the highest and the second highest Emissions (1000 metric ton of CO2 equivalent) of 2000?
Your answer should be very brief. 2.81e+05. What is the difference between the highest and the second highest Emissions (1000 metric ton of CO2 equivalent) of 2005?
Offer a very short reply. 3.23e+05. What is the difference between the highest and the second highest Emissions (1000 metric ton of CO2 equivalent) of 2008?
Make the answer very short. 3.52e+05. What is the difference between the highest and the lowest Emissions (1000 metric ton of CO2 equivalent) in 1990?
Keep it short and to the point. 2.49e+05. What is the difference between the highest and the lowest Emissions (1000 metric ton of CO2 equivalent) of 2000?
Ensure brevity in your answer.  2.98e+05. What is the difference between the highest and the lowest Emissions (1000 metric ton of CO2 equivalent) of 2005?
Keep it short and to the point. 3.41e+05. What is the difference between the highest and the lowest Emissions (1000 metric ton of CO2 equivalent) of 2008?
Your response must be concise. 3.69e+05. 